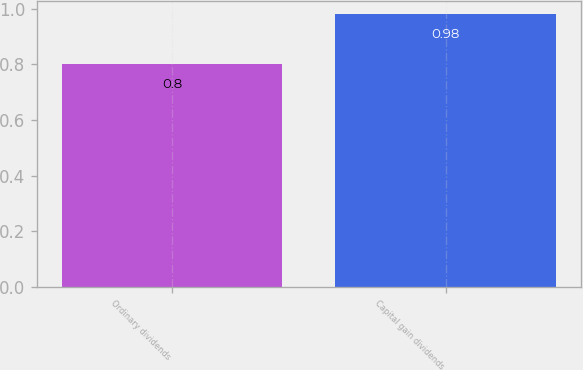Convert chart. <chart><loc_0><loc_0><loc_500><loc_500><bar_chart><fcel>Ordinary dividends<fcel>Capital gain dividends<nl><fcel>0.8<fcel>0.98<nl></chart> 